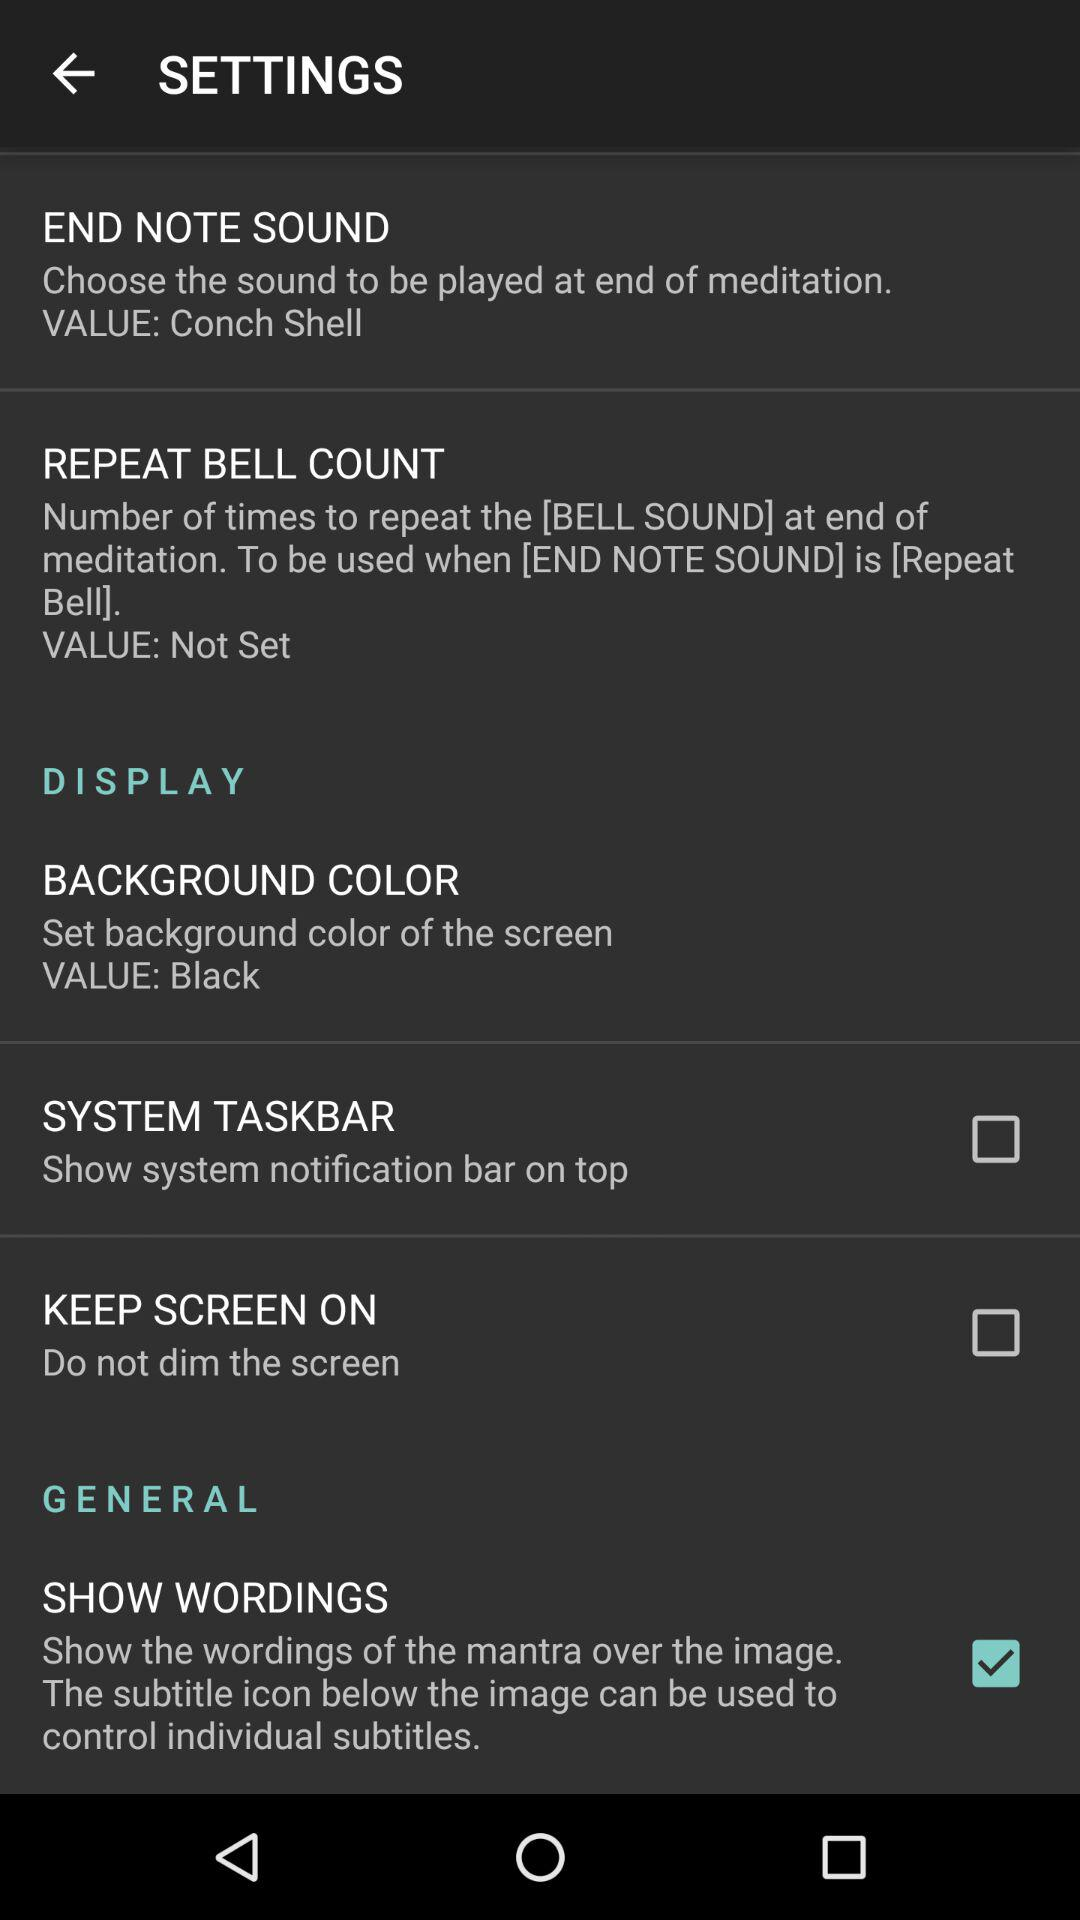What is the current status of "SYSTEM TASKBAR"? The current status of "SYSTEM TASKBAR" is "off". 